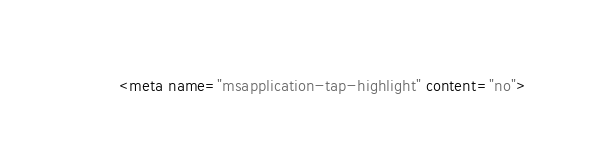Convert code to text. <code><loc_0><loc_0><loc_500><loc_500><_HTML_>        <meta name="msapplication-tap-highlight" content="no"></code> 